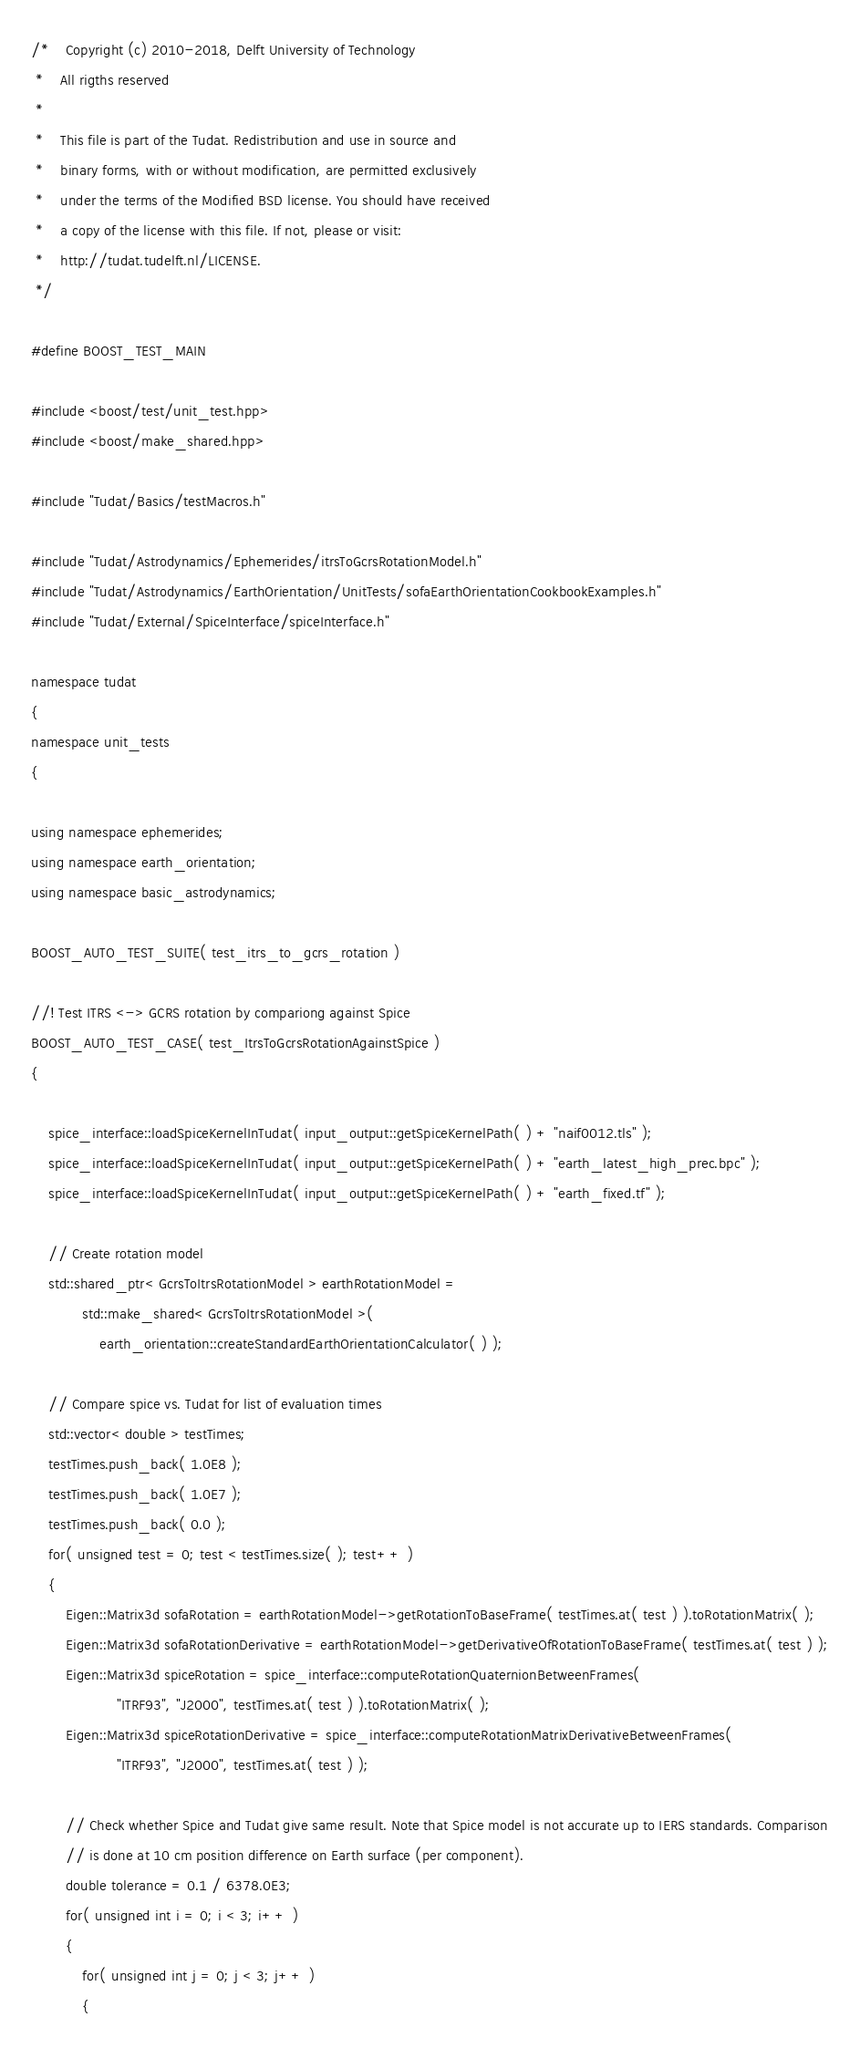<code> <loc_0><loc_0><loc_500><loc_500><_C++_>/*    Copyright (c) 2010-2018, Delft University of Technology
 *    All rigths reserved
 *
 *    This file is part of the Tudat. Redistribution and use in source and
 *    binary forms, with or without modification, are permitted exclusively
 *    under the terms of the Modified BSD license. You should have received
 *    a copy of the license with this file. If not, please or visit:
 *    http://tudat.tudelft.nl/LICENSE.
 */

#define BOOST_TEST_MAIN

#include <boost/test/unit_test.hpp>
#include <boost/make_shared.hpp>

#include "Tudat/Basics/testMacros.h"

#include "Tudat/Astrodynamics/Ephemerides/itrsToGcrsRotationModel.h"
#include "Tudat/Astrodynamics/EarthOrientation/UnitTests/sofaEarthOrientationCookbookExamples.h"
#include "Tudat/External/SpiceInterface/spiceInterface.h"

namespace tudat
{
namespace unit_tests
{

using namespace ephemerides;
using namespace earth_orientation;
using namespace basic_astrodynamics;

BOOST_AUTO_TEST_SUITE( test_itrs_to_gcrs_rotation )

//! Test ITRS <-> GCRS rotation by compariong against Spice
BOOST_AUTO_TEST_CASE( test_ItrsToGcrsRotationAgainstSpice )
{

    spice_interface::loadSpiceKernelInTudat( input_output::getSpiceKernelPath( ) + "naif0012.tls" );
    spice_interface::loadSpiceKernelInTudat( input_output::getSpiceKernelPath( ) + "earth_latest_high_prec.bpc" );
    spice_interface::loadSpiceKernelInTudat( input_output::getSpiceKernelPath( ) + "earth_fixed.tf" );

    // Create rotation model
    std::shared_ptr< GcrsToItrsRotationModel > earthRotationModel =
            std::make_shared< GcrsToItrsRotationModel >(
                earth_orientation::createStandardEarthOrientationCalculator( ) );

    // Compare spice vs. Tudat for list of evaluation times
    std::vector< double > testTimes;
    testTimes.push_back( 1.0E8 );
    testTimes.push_back( 1.0E7 );
    testTimes.push_back( 0.0 );
    for( unsigned test = 0; test < testTimes.size( ); test++ )
    {
        Eigen::Matrix3d sofaRotation = earthRotationModel->getRotationToBaseFrame( testTimes.at( test ) ).toRotationMatrix( );
        Eigen::Matrix3d sofaRotationDerivative = earthRotationModel->getDerivativeOfRotationToBaseFrame( testTimes.at( test ) );
        Eigen::Matrix3d spiceRotation = spice_interface::computeRotationQuaternionBetweenFrames(
                    "ITRF93", "J2000", testTimes.at( test ) ).toRotationMatrix( );
        Eigen::Matrix3d spiceRotationDerivative = spice_interface::computeRotationMatrixDerivativeBetweenFrames(
                    "ITRF93", "J2000", testTimes.at( test ) );

        // Check whether Spice and Tudat give same result. Note that Spice model is not accurate up to IERS standards. Comparison
        // is done at 10 cm position difference on Earth surface (per component).
        double tolerance = 0.1 / 6378.0E3;
        for( unsigned int i = 0; i < 3; i++ )
        {
            for( unsigned int j = 0; j < 3; j++ )
            {</code> 